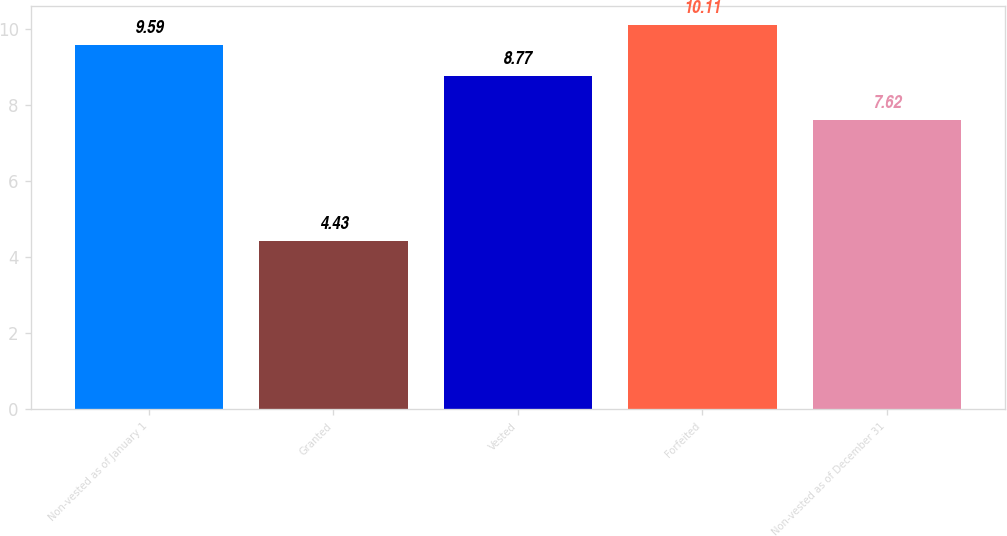Convert chart. <chart><loc_0><loc_0><loc_500><loc_500><bar_chart><fcel>Non-vested as of January 1<fcel>Granted<fcel>Vested<fcel>Forfeited<fcel>Non-vested as of December 31<nl><fcel>9.59<fcel>4.43<fcel>8.77<fcel>10.11<fcel>7.62<nl></chart> 